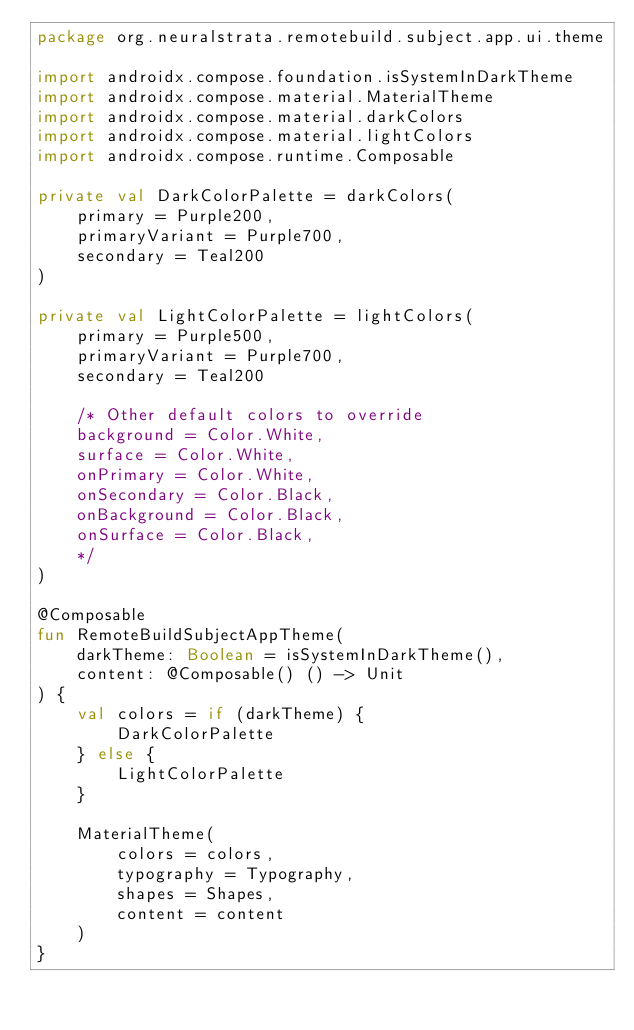<code> <loc_0><loc_0><loc_500><loc_500><_Kotlin_>package org.neuralstrata.remotebuild.subject.app.ui.theme

import androidx.compose.foundation.isSystemInDarkTheme
import androidx.compose.material.MaterialTheme
import androidx.compose.material.darkColors
import androidx.compose.material.lightColors
import androidx.compose.runtime.Composable

private val DarkColorPalette = darkColors(
    primary = Purple200,
    primaryVariant = Purple700,
    secondary = Teal200
)

private val LightColorPalette = lightColors(
    primary = Purple500,
    primaryVariant = Purple700,
    secondary = Teal200

    /* Other default colors to override
    background = Color.White,
    surface = Color.White,
    onPrimary = Color.White,
    onSecondary = Color.Black,
    onBackground = Color.Black,
    onSurface = Color.Black,
    */
)

@Composable
fun RemoteBuildSubjectAppTheme(
    darkTheme: Boolean = isSystemInDarkTheme(),
    content: @Composable() () -> Unit
) {
    val colors = if (darkTheme) {
        DarkColorPalette
    } else {
        LightColorPalette
    }

    MaterialTheme(
        colors = colors,
        typography = Typography,
        shapes = Shapes,
        content = content
    )
}</code> 